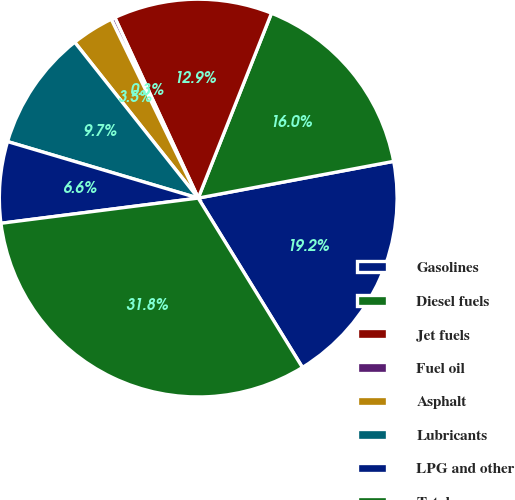<chart> <loc_0><loc_0><loc_500><loc_500><pie_chart><fcel>Gasolines<fcel>Diesel fuels<fcel>Jet fuels<fcel>Fuel oil<fcel>Asphalt<fcel>Lubricants<fcel>LPG and other<fcel>Total<nl><fcel>19.18%<fcel>16.04%<fcel>12.89%<fcel>0.32%<fcel>3.46%<fcel>9.75%<fcel>6.61%<fcel>31.76%<nl></chart> 